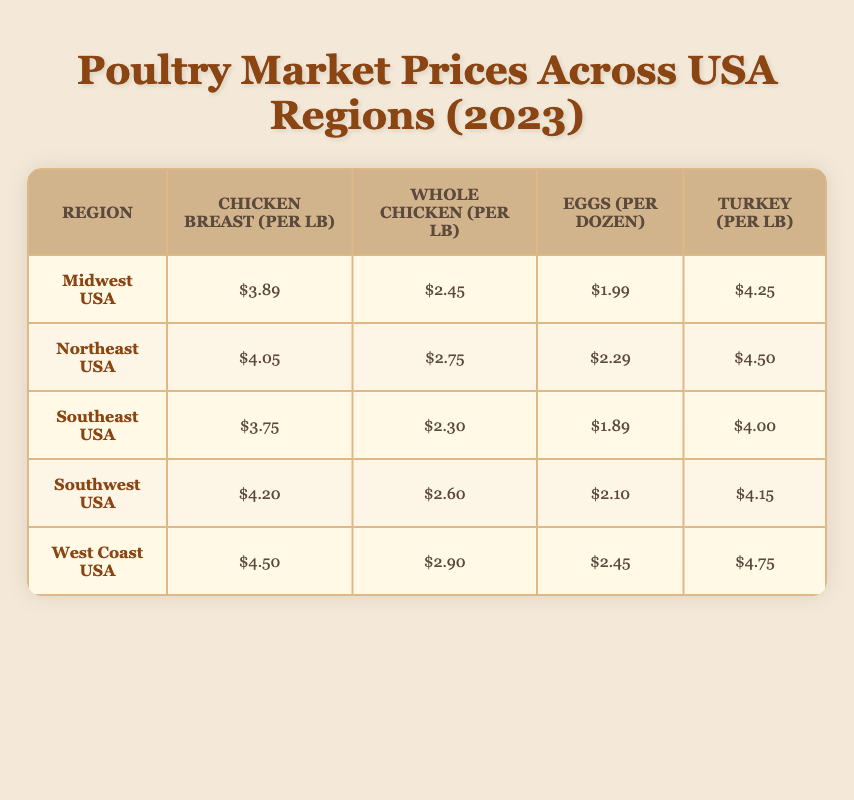What is the price of chicken breast in the Midwest USA? The table shows that the price for chicken breast in the Midwest USA is $3.89 per lb as listed.
Answer: 3.89 Which region has the highest price for whole chicken? According to the table, the West Coast USA has the highest price for whole chicken at $2.90 per lb.
Answer: 2.90 What is the average price of eggs across all regions? To find the average price of eggs, add all the prices: (1.99 + 2.29 + 1.89 + 2.10 + 2.45) = 10.72. Then divide by the number of regions (5): 10.72 / 5 = 2.144. Therefore, the average price of eggs is approximately $2.14.
Answer: 2.14 Is the price of turkey in the Northeast USA higher than that in the Southeast USA? The table shows the turkey price in the Northeast USA is $4.50, while in the Southeast USA, it is $4.00. Since $4.50 is greater than $4.00, the statement is true.
Answer: Yes Which region has the lowest price for chicken breast and how much is it? Looking at the table, the Southeast USA has the lowest price for chicken breast at $3.75 per lb.
Answer: 3.75 What is the price difference for whole chicken between the Northeast USA and the Southwest USA? The price for whole chicken in the Northeast USA is $2.75 and in the Southwest USA is $2.60. The difference is $2.75 - $2.60 = $0.15.
Answer: 0.15 How do the prices of turkey compare between the Midwest and Southwest USA? The Midwest USA price for turkey is $4.25, and the Southwest USA price is $4.15. Since $4.25 is greater than $4.15, the turkey price in the Midwest is higher.
Answer: Yes What are the prices of chicken breast and turkey in the West Coast USA? The table lists the price of chicken breast in the West Coast USA as $4.50 per lb and turkey as $4.75 per lb.
Answer: Chicken breast: 4.50, Turkey: 4.75 What is the total cost for a dozen eggs and a whole chicken in the Southeast USA? In the Southeast USA, the price for eggs is $1.89 per dozen and a whole chicken is $2.30 per lb. The total cost is $1.89 + $2.30 = $4.19.
Answer: 4.19 